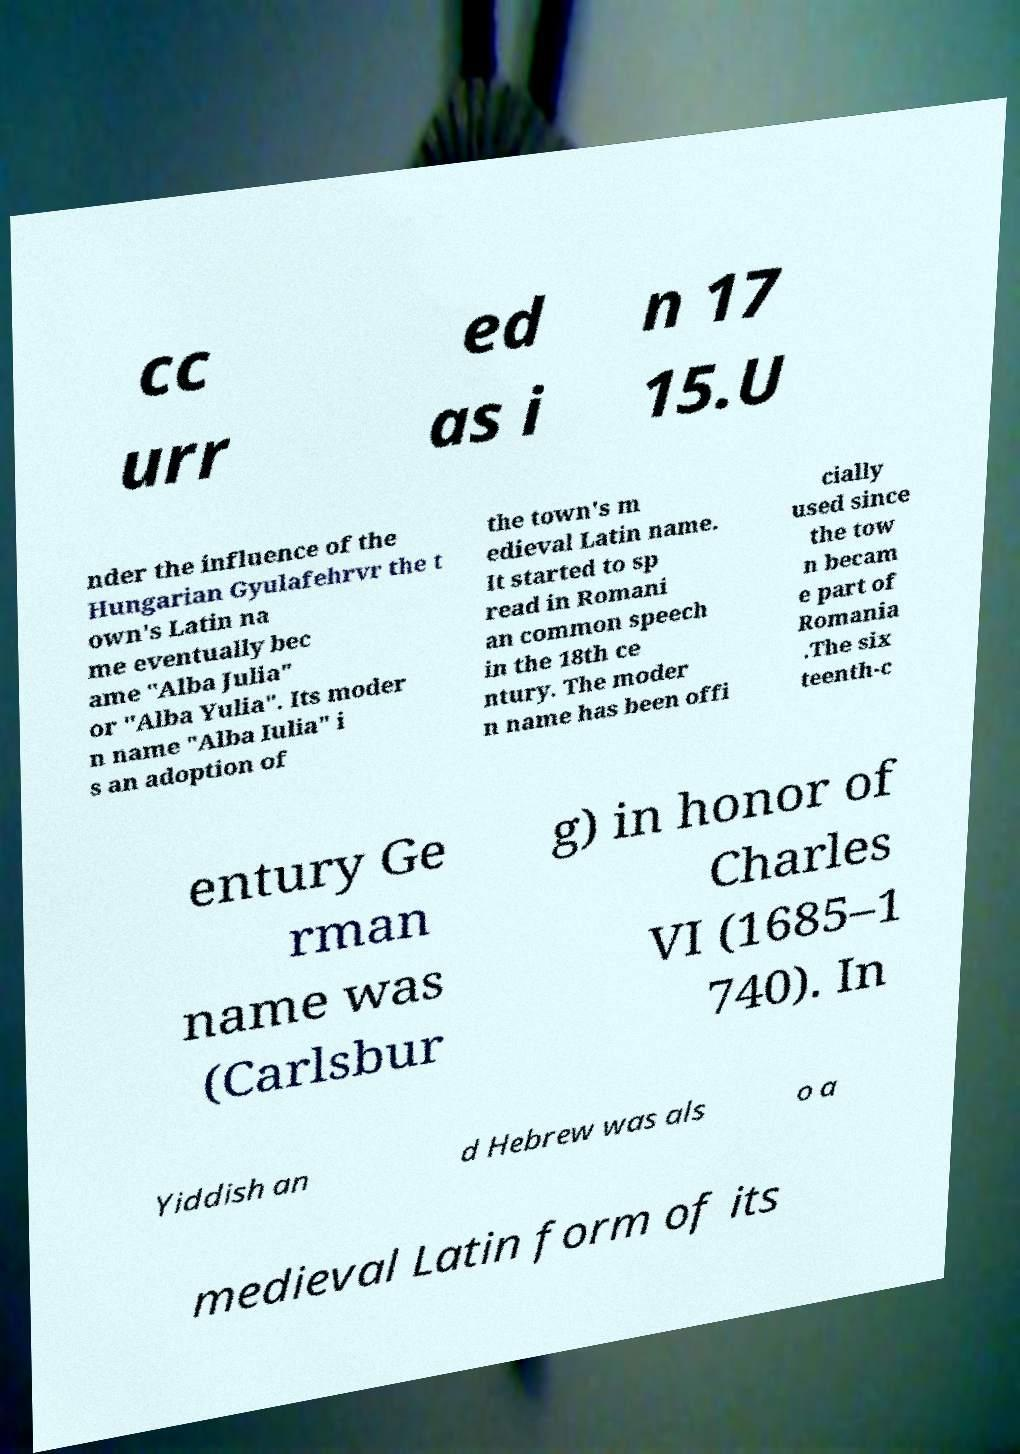I need the written content from this picture converted into text. Can you do that? cc urr ed as i n 17 15.U nder the influence of the Hungarian Gyulafehrvr the t own's Latin na me eventually bec ame "Alba Julia" or "Alba Yulia". Its moder n name "Alba Iulia" i s an adoption of the town's m edieval Latin name. It started to sp read in Romani an common speech in the 18th ce ntury. The moder n name has been offi cially used since the tow n becam e part of Romania .The six teenth-c entury Ge rman name was (Carlsbur g) in honor of Charles VI (1685–1 740). In Yiddish an d Hebrew was als o a medieval Latin form of its 